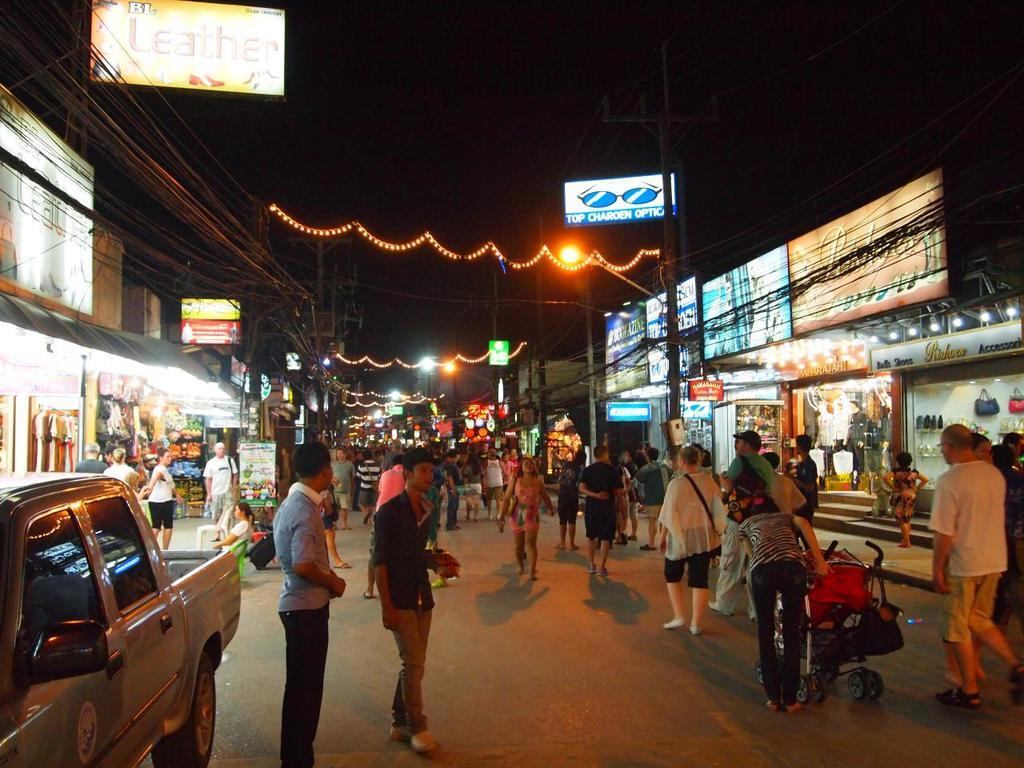Who or what is present in the image? There are people in the image. What else can be seen on the road in the image? There are vehicles on the road in the image. What type of establishments are located beside the road? There are shops beside the road in the image. How many tents are set up in the image? There are no tents present in the image. What type of knot is being used to secure the vehicles in the image? There is no knot visible in the image, as the vehicles are not tied down. 